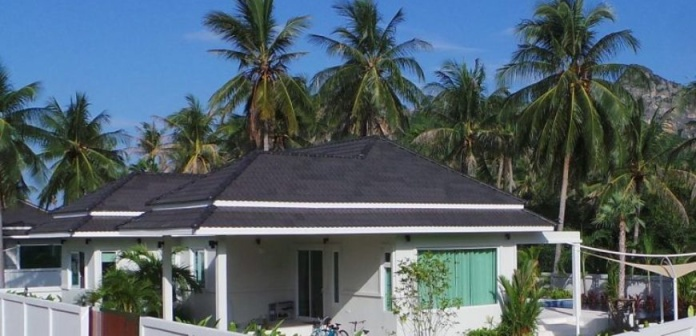How does the environment contribute to the atmosphere of the scene? The environment plays a crucial role in setting the tranquil and idyllic atmosphere of the scene. The lush palm trees not only enhance the tropical vibe but also bring a sense of vitality and nature's embrace. The mist-enshrouded mountains in the background add a layer of mystery and majesty, contributing to a feeling of escapism and solitude. This interaction between the natural elements and the man-made bungalow creates a harmonious and peaceful setting, ideal for those looking to unwind and reconnect with nature. 